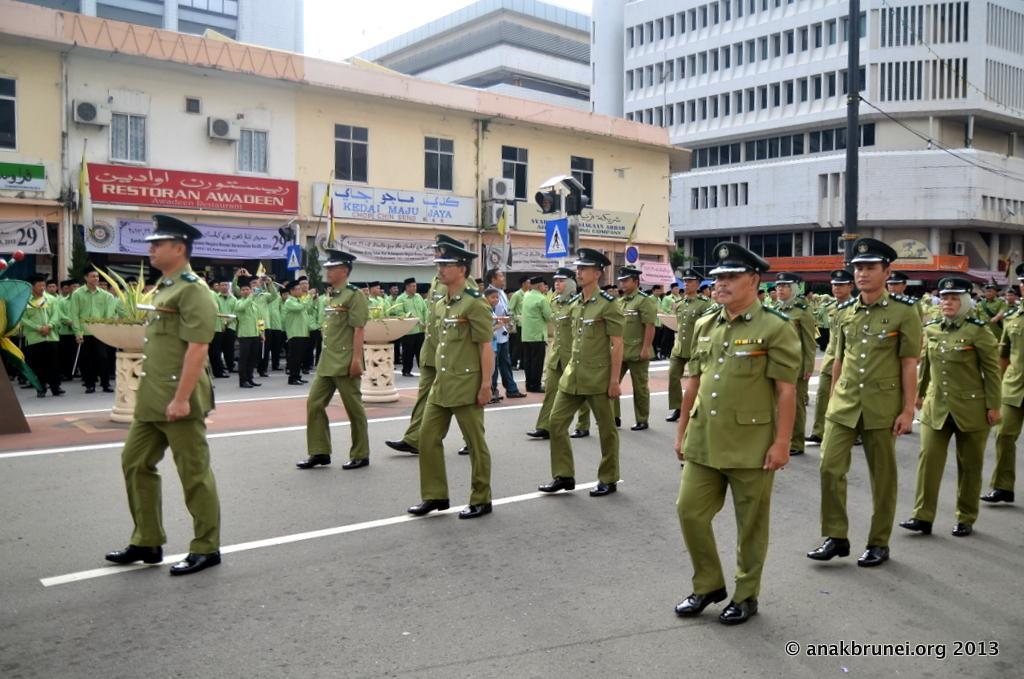Please provide a concise description of this image. In this picture I can see group of people among them some are standing on the road. These people are wearing uniforms and hats. In the background i can see buildings, trees, boards and sign board. On the right side I can see a pole which has wires. In the background I can see the sky. 